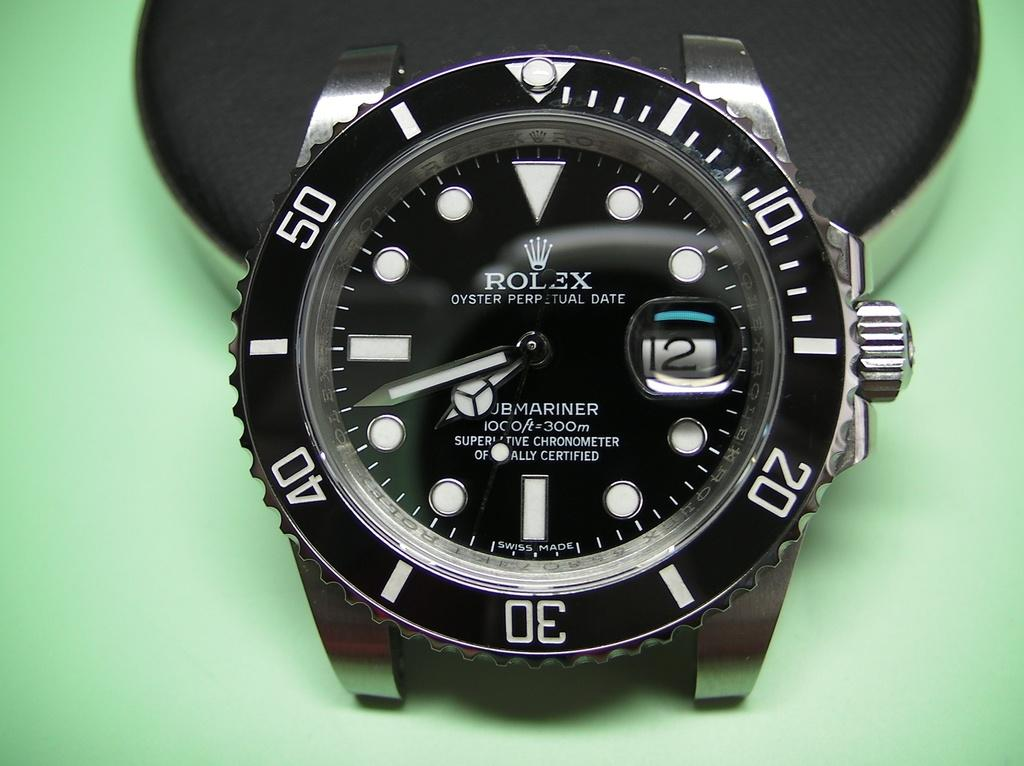Provide a one-sentence caption for the provided image. A black face Rolex watch with white numbers that has no wristband. 